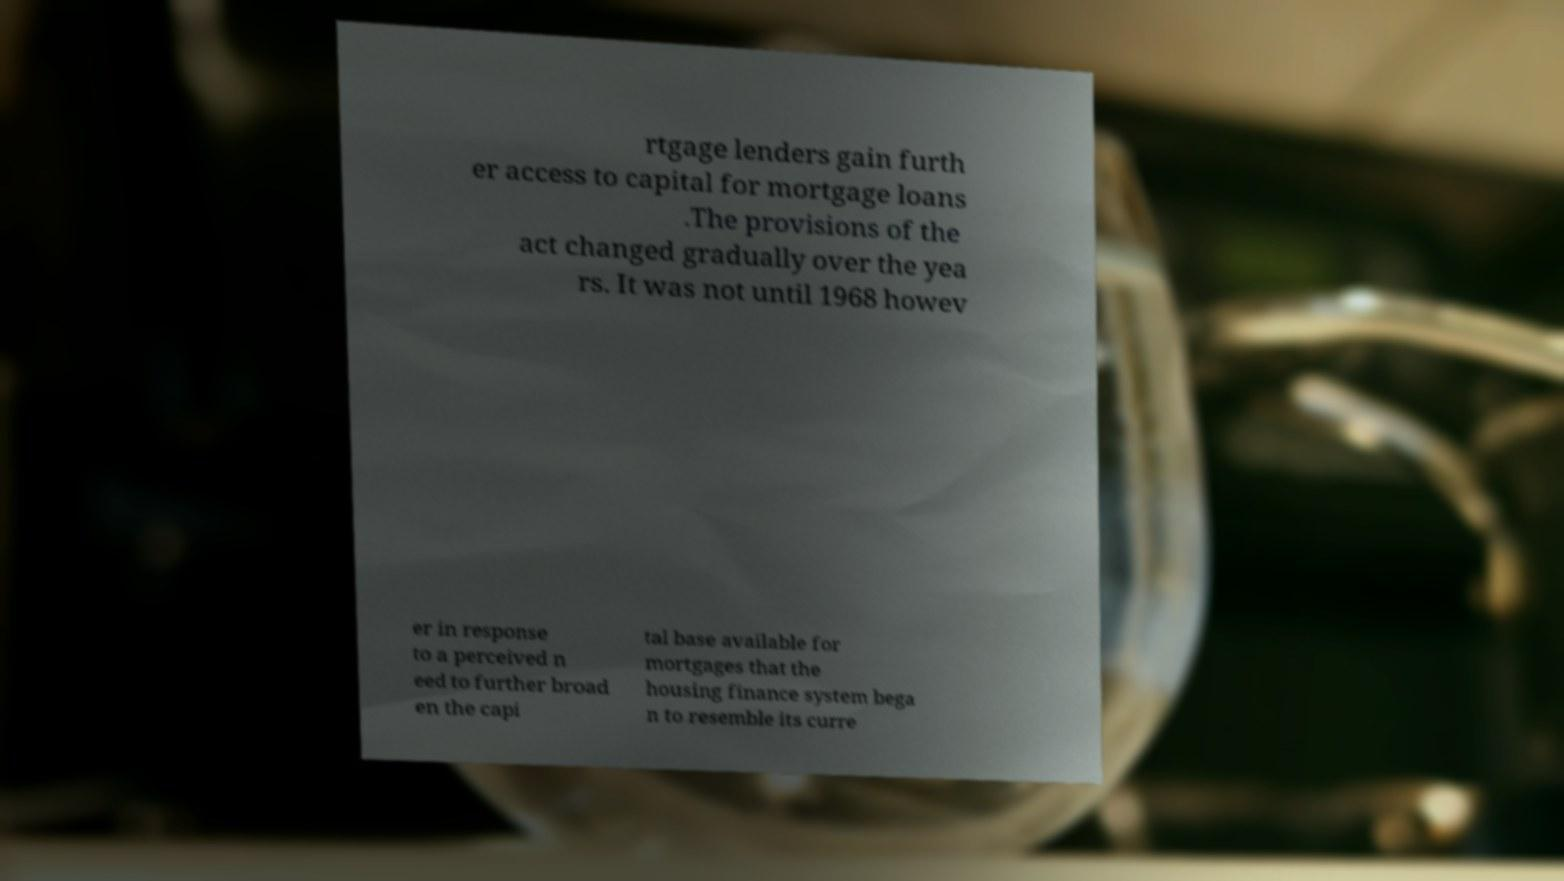Could you assist in decoding the text presented in this image and type it out clearly? rtgage lenders gain furth er access to capital for mortgage loans .The provisions of the act changed gradually over the yea rs. It was not until 1968 howev er in response to a perceived n eed to further broad en the capi tal base available for mortgages that the housing finance system bega n to resemble its curre 